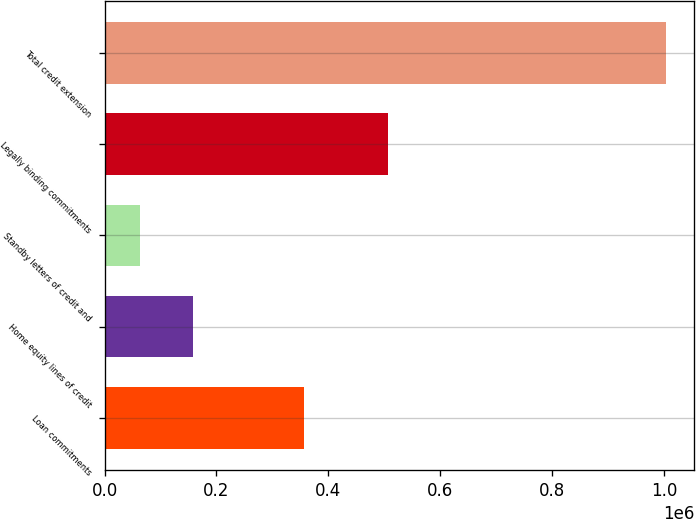<chart> <loc_0><loc_0><loc_500><loc_500><bar_chart><fcel>Loan commitments<fcel>Home equity lines of credit<fcel>Standby letters of credit and<fcel>Legally binding commitments<fcel>Total credit extension<nl><fcel>357024<fcel>158144<fcel>64256<fcel>506067<fcel>1.00314e+06<nl></chart> 